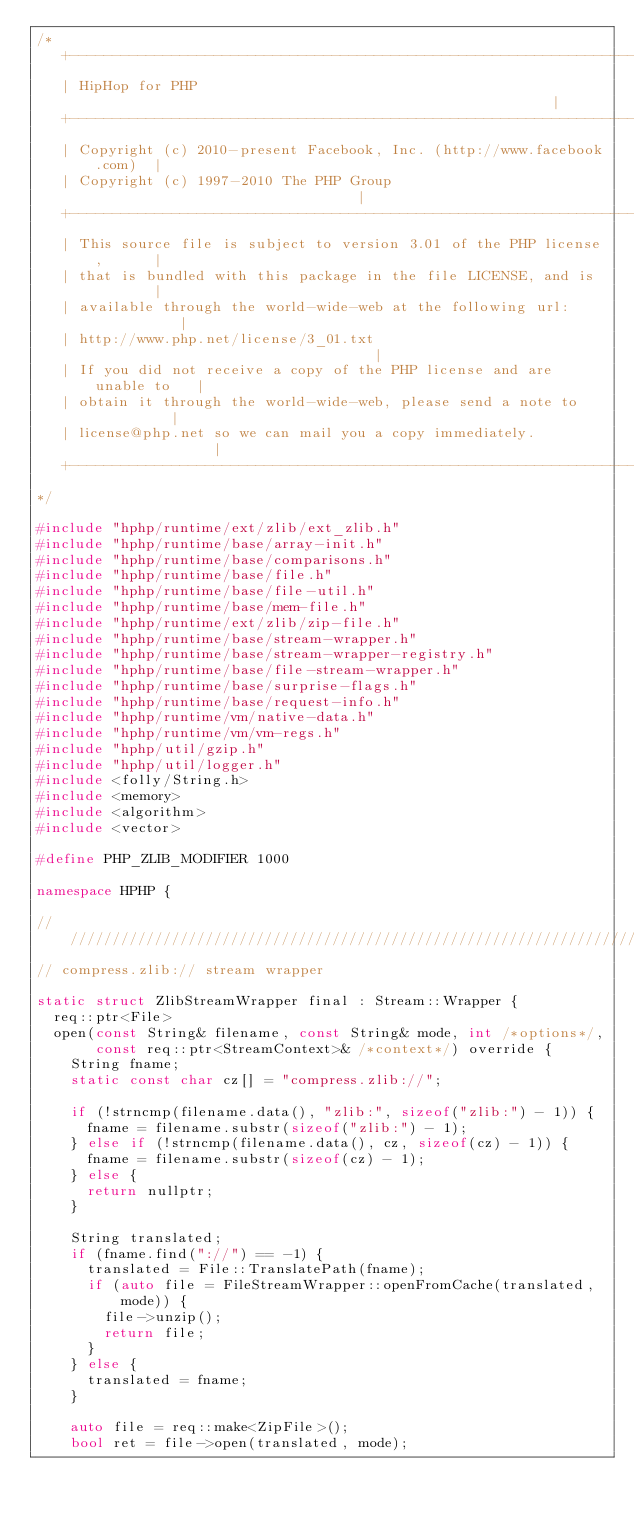<code> <loc_0><loc_0><loc_500><loc_500><_C++_>/*
   +----------------------------------------------------------------------+
   | HipHop for PHP                                                       |
   +----------------------------------------------------------------------+
   | Copyright (c) 2010-present Facebook, Inc. (http://www.facebook.com)  |
   | Copyright (c) 1997-2010 The PHP Group                                |
   +----------------------------------------------------------------------+
   | This source file is subject to version 3.01 of the PHP license,      |
   | that is bundled with this package in the file LICENSE, and is        |
   | available through the world-wide-web at the following url:           |
   | http://www.php.net/license/3_01.txt                                  |
   | If you did not receive a copy of the PHP license and are unable to   |
   | obtain it through the world-wide-web, please send a note to          |
   | license@php.net so we can mail you a copy immediately.               |
   +----------------------------------------------------------------------+
*/

#include "hphp/runtime/ext/zlib/ext_zlib.h"
#include "hphp/runtime/base/array-init.h"
#include "hphp/runtime/base/comparisons.h"
#include "hphp/runtime/base/file.h"
#include "hphp/runtime/base/file-util.h"
#include "hphp/runtime/base/mem-file.h"
#include "hphp/runtime/ext/zlib/zip-file.h"
#include "hphp/runtime/base/stream-wrapper.h"
#include "hphp/runtime/base/stream-wrapper-registry.h"
#include "hphp/runtime/base/file-stream-wrapper.h"
#include "hphp/runtime/base/surprise-flags.h"
#include "hphp/runtime/base/request-info.h"
#include "hphp/runtime/vm/native-data.h"
#include "hphp/runtime/vm/vm-regs.h"
#include "hphp/util/gzip.h"
#include "hphp/util/logger.h"
#include <folly/String.h>
#include <memory>
#include <algorithm>
#include <vector>

#define PHP_ZLIB_MODIFIER 1000

namespace HPHP {

///////////////////////////////////////////////////////////////////////////////
// compress.zlib:// stream wrapper

static struct ZlibStreamWrapper final : Stream::Wrapper {
  req::ptr<File>
  open(const String& filename, const String& mode, int /*options*/,
       const req::ptr<StreamContext>& /*context*/) override {
    String fname;
    static const char cz[] = "compress.zlib://";

    if (!strncmp(filename.data(), "zlib:", sizeof("zlib:") - 1)) {
      fname = filename.substr(sizeof("zlib:") - 1);
    } else if (!strncmp(filename.data(), cz, sizeof(cz) - 1)) {
      fname = filename.substr(sizeof(cz) - 1);
    } else {
      return nullptr;
    }

    String translated;
    if (fname.find("://") == -1) {
      translated = File::TranslatePath(fname);
      if (auto file = FileStreamWrapper::openFromCache(translated, mode)) {
        file->unzip();
        return file;
      }
    } else {
      translated = fname;
    }

    auto file = req::make<ZipFile>();
    bool ret = file->open(translated, mode);</code> 